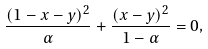Convert formula to latex. <formula><loc_0><loc_0><loc_500><loc_500>\frac { ( 1 - x - y ) ^ { 2 } } { \alpha } + \frac { ( x - y ) ^ { 2 } } { 1 - \alpha } = 0 ,</formula> 